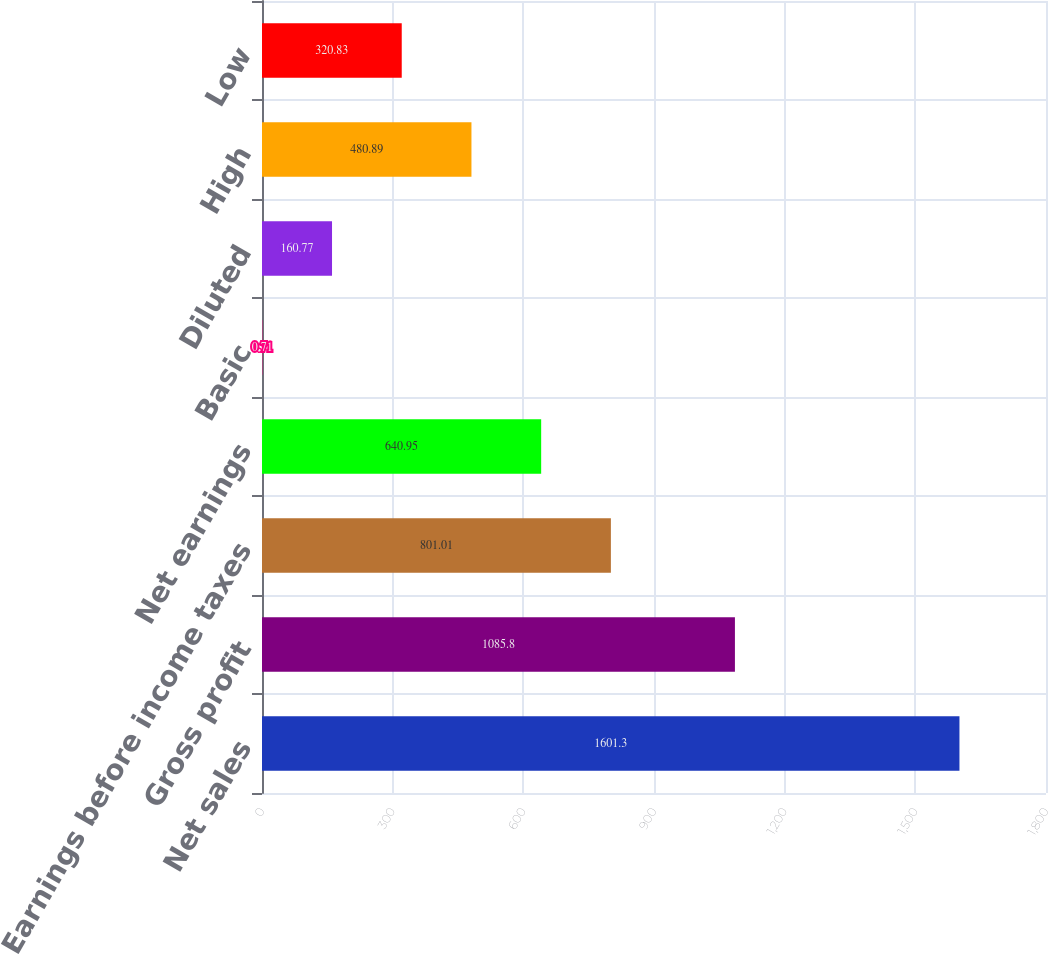<chart> <loc_0><loc_0><loc_500><loc_500><bar_chart><fcel>Net sales<fcel>Gross profit<fcel>Earnings before income taxes<fcel>Net earnings<fcel>Basic<fcel>Diluted<fcel>High<fcel>Low<nl><fcel>1601.3<fcel>1085.8<fcel>801.01<fcel>640.95<fcel>0.71<fcel>160.77<fcel>480.89<fcel>320.83<nl></chart> 